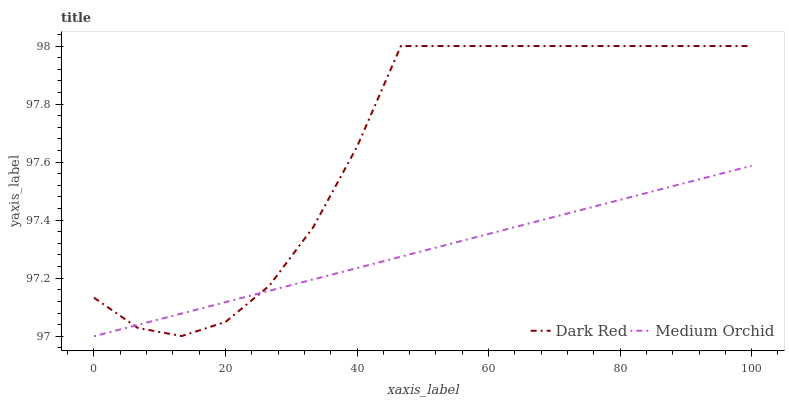Does Medium Orchid have the minimum area under the curve?
Answer yes or no. Yes. Does Dark Red have the maximum area under the curve?
Answer yes or no. Yes. Does Medium Orchid have the maximum area under the curve?
Answer yes or no. No. Is Medium Orchid the smoothest?
Answer yes or no. Yes. Is Dark Red the roughest?
Answer yes or no. Yes. Is Medium Orchid the roughest?
Answer yes or no. No. Does Medium Orchid have the lowest value?
Answer yes or no. Yes. Does Dark Red have the highest value?
Answer yes or no. Yes. Does Medium Orchid have the highest value?
Answer yes or no. No. Does Dark Red intersect Medium Orchid?
Answer yes or no. Yes. Is Dark Red less than Medium Orchid?
Answer yes or no. No. Is Dark Red greater than Medium Orchid?
Answer yes or no. No. 